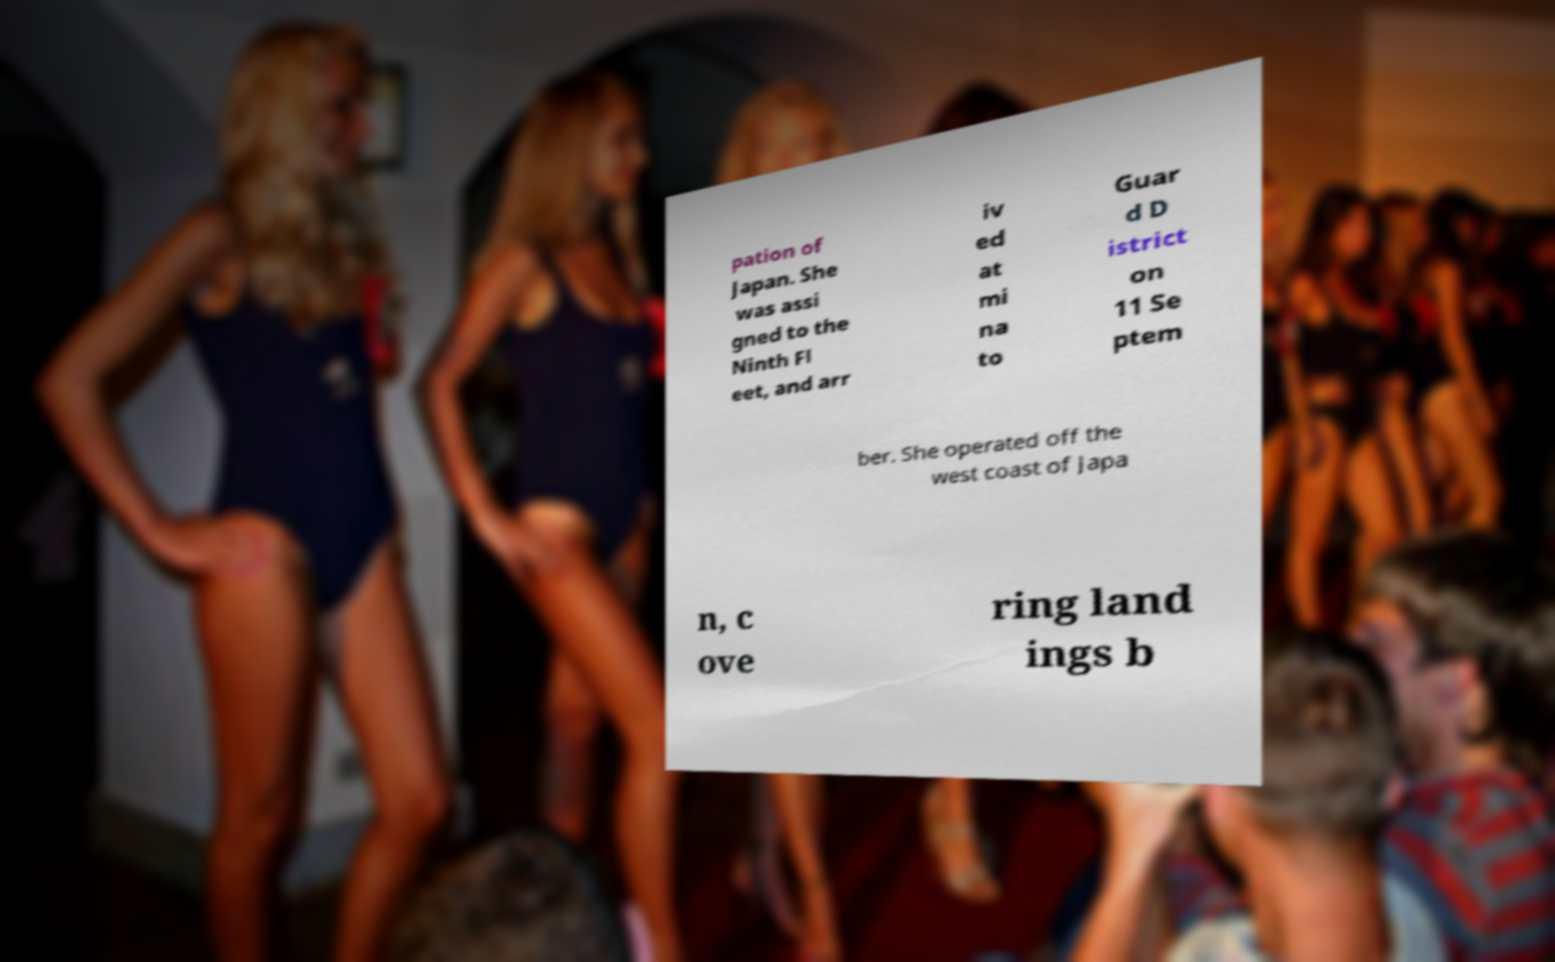There's text embedded in this image that I need extracted. Can you transcribe it verbatim? pation of Japan. She was assi gned to the Ninth Fl eet, and arr iv ed at mi na to Guar d D istrict on 11 Se ptem ber. She operated off the west coast of Japa n, c ove ring land ings b 